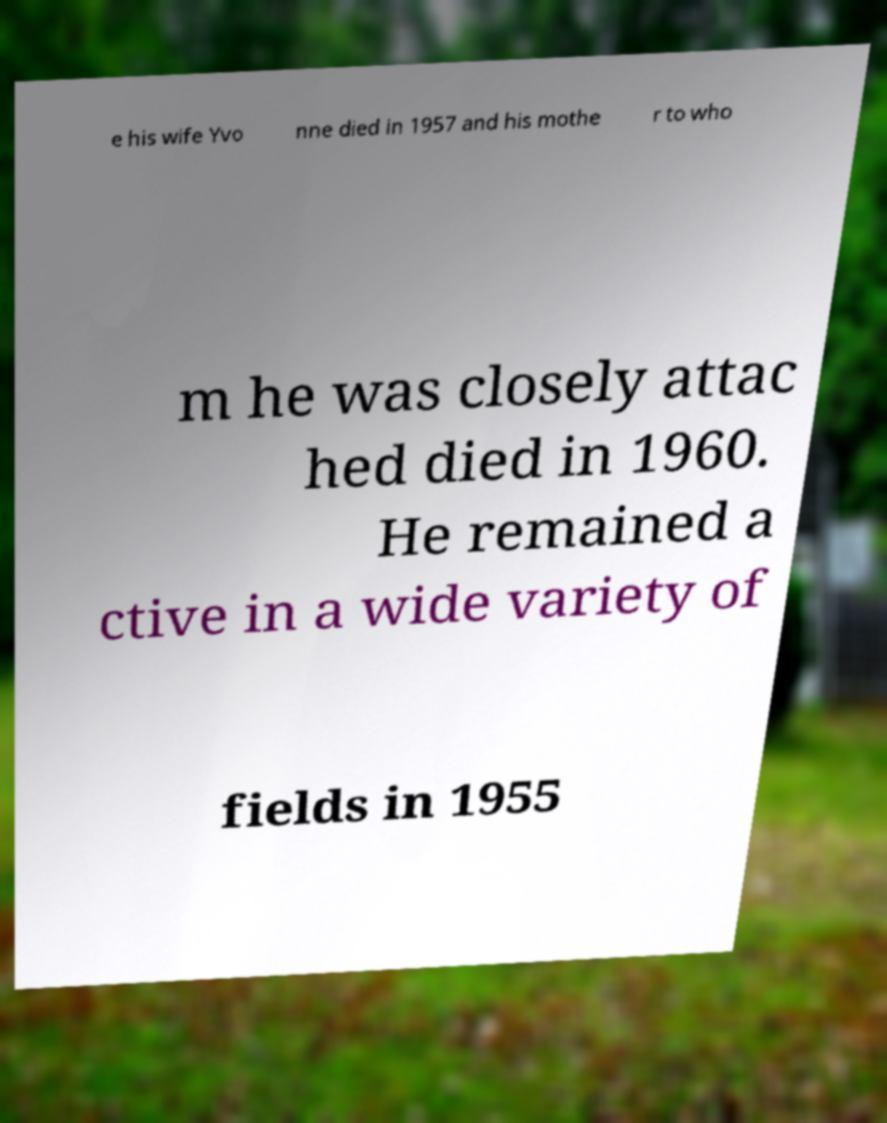Could you extract and type out the text from this image? e his wife Yvo nne died in 1957 and his mothe r to who m he was closely attac hed died in 1960. He remained a ctive in a wide variety of fields in 1955 